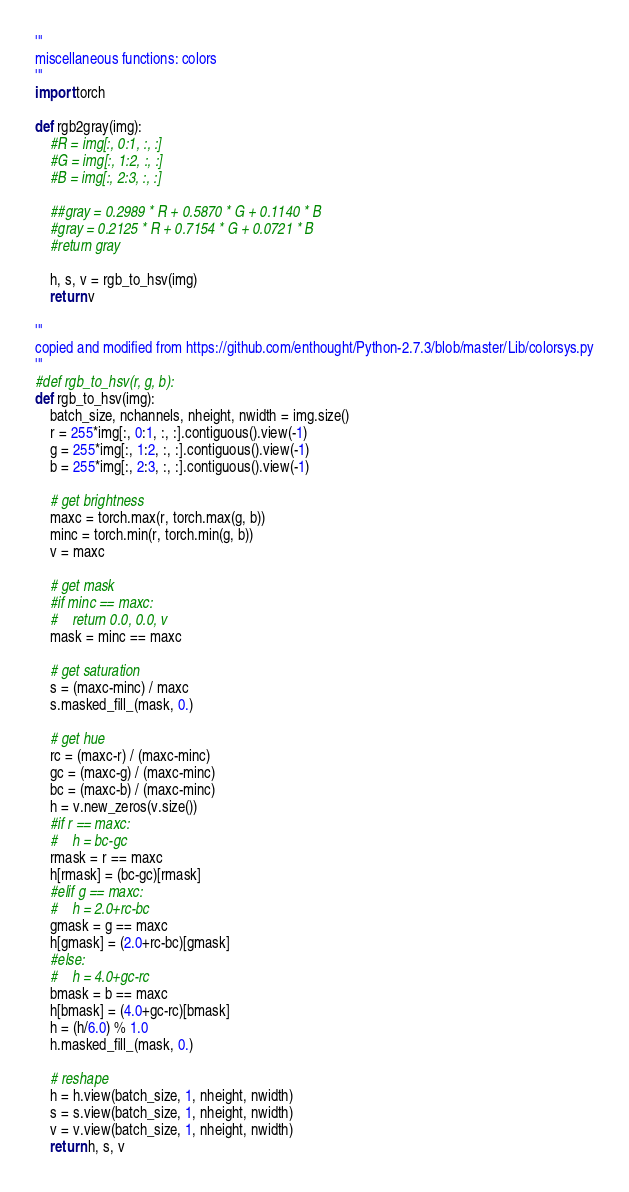<code> <loc_0><loc_0><loc_500><loc_500><_Python_>'''
miscellaneous functions: colors
'''
import torch

def rgb2gray(img):
    #R = img[:, 0:1, :, :]
    #G = img[:, 1:2, :, :]
    #B = img[:, 2:3, :, :]

    ##gray = 0.2989 * R + 0.5870 * G + 0.1140 * B
    #gray = 0.2125 * R + 0.7154 * G + 0.0721 * B
    #return gray

    h, s, v = rgb_to_hsv(img)
    return v

'''
copied and modified from https://github.com/enthought/Python-2.7.3/blob/master/Lib/colorsys.py
'''
#def rgb_to_hsv(r, g, b):
def rgb_to_hsv(img):
    batch_size, nchannels, nheight, nwidth = img.size()
    r = 255*img[:, 0:1, :, :].contiguous().view(-1)
    g = 255*img[:, 1:2, :, :].contiguous().view(-1)
    b = 255*img[:, 2:3, :, :].contiguous().view(-1)

    # get brightness
    maxc = torch.max(r, torch.max(g, b))
    minc = torch.min(r, torch.min(g, b))
    v = maxc

    # get mask
    #if minc == maxc:
    #    return 0.0, 0.0, v
    mask = minc == maxc

    # get saturation
    s = (maxc-minc) / maxc
    s.masked_fill_(mask, 0.)

    # get hue
    rc = (maxc-r) / (maxc-minc)
    gc = (maxc-g) / (maxc-minc)
    bc = (maxc-b) / (maxc-minc)
    h = v.new_zeros(v.size())
    #if r == maxc:
    #    h = bc-gc
    rmask = r == maxc
    h[rmask] = (bc-gc)[rmask]
    #elif g == maxc:
    #    h = 2.0+rc-bc
    gmask = g == maxc
    h[gmask] = (2.0+rc-bc)[gmask]
    #else:
    #    h = 4.0+gc-rc
    bmask = b == maxc
    h[bmask] = (4.0+gc-rc)[bmask]
    h = (h/6.0) % 1.0
    h.masked_fill_(mask, 0.)

    # reshape
    h = h.view(batch_size, 1, nheight, nwidth)
    s = s.view(batch_size, 1, nheight, nwidth)
    v = v.view(batch_size, 1, nheight, nwidth)
    return h, s, v
</code> 